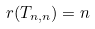Convert formula to latex. <formula><loc_0><loc_0><loc_500><loc_500>r ( T _ { n , n } ) = n</formula> 